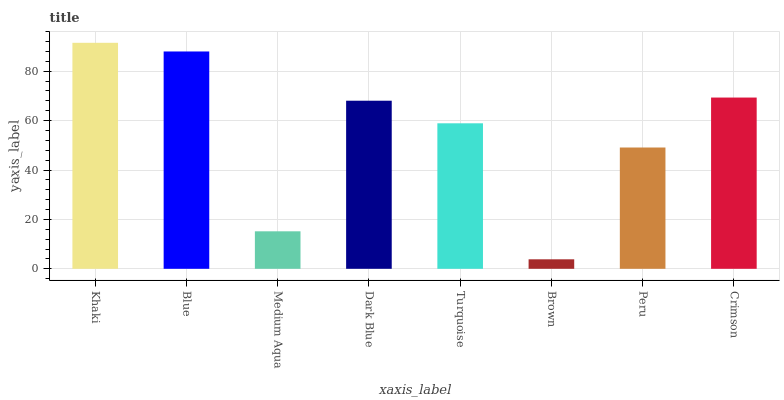Is Brown the minimum?
Answer yes or no. Yes. Is Khaki the maximum?
Answer yes or no. Yes. Is Blue the minimum?
Answer yes or no. No. Is Blue the maximum?
Answer yes or no. No. Is Khaki greater than Blue?
Answer yes or no. Yes. Is Blue less than Khaki?
Answer yes or no. Yes. Is Blue greater than Khaki?
Answer yes or no. No. Is Khaki less than Blue?
Answer yes or no. No. Is Dark Blue the high median?
Answer yes or no. Yes. Is Turquoise the low median?
Answer yes or no. Yes. Is Blue the high median?
Answer yes or no. No. Is Dark Blue the low median?
Answer yes or no. No. 